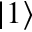<formula> <loc_0><loc_0><loc_500><loc_500>| 1 \rangle</formula> 